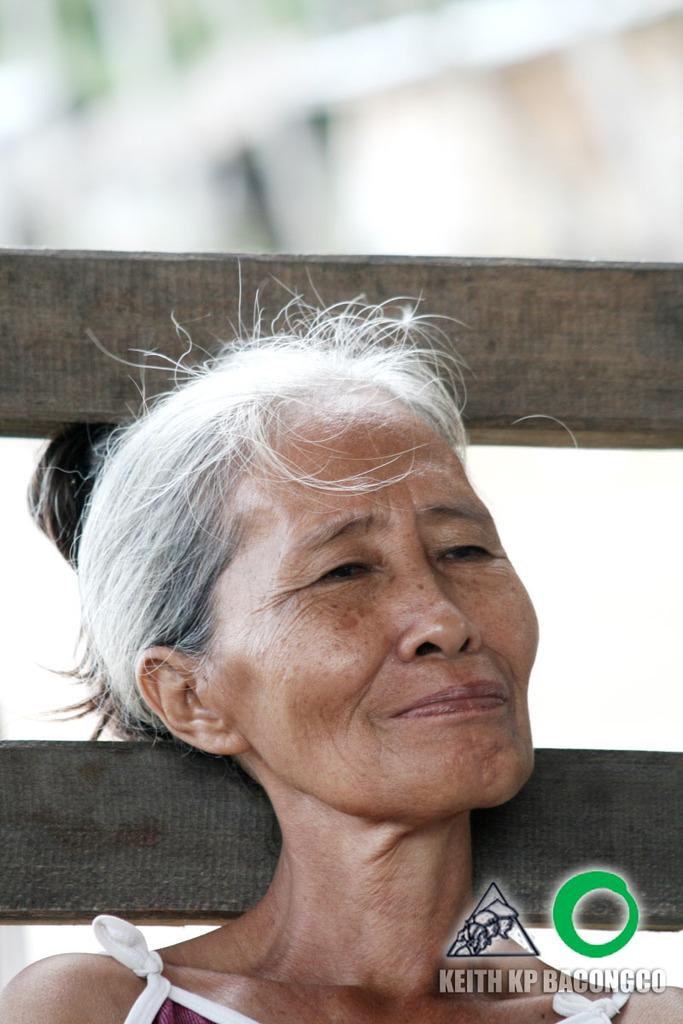Who is present in the image? There is a woman in the image. What type of alarm is the woman holding in the image? There is no alarm present in the image; it only features a woman. Can you see the woman's veins in the image? The image does not provide enough detail to see the woman's veins. What is the woman doing with her foot in the image? There is no foot or action involving a foot visible in the image. 